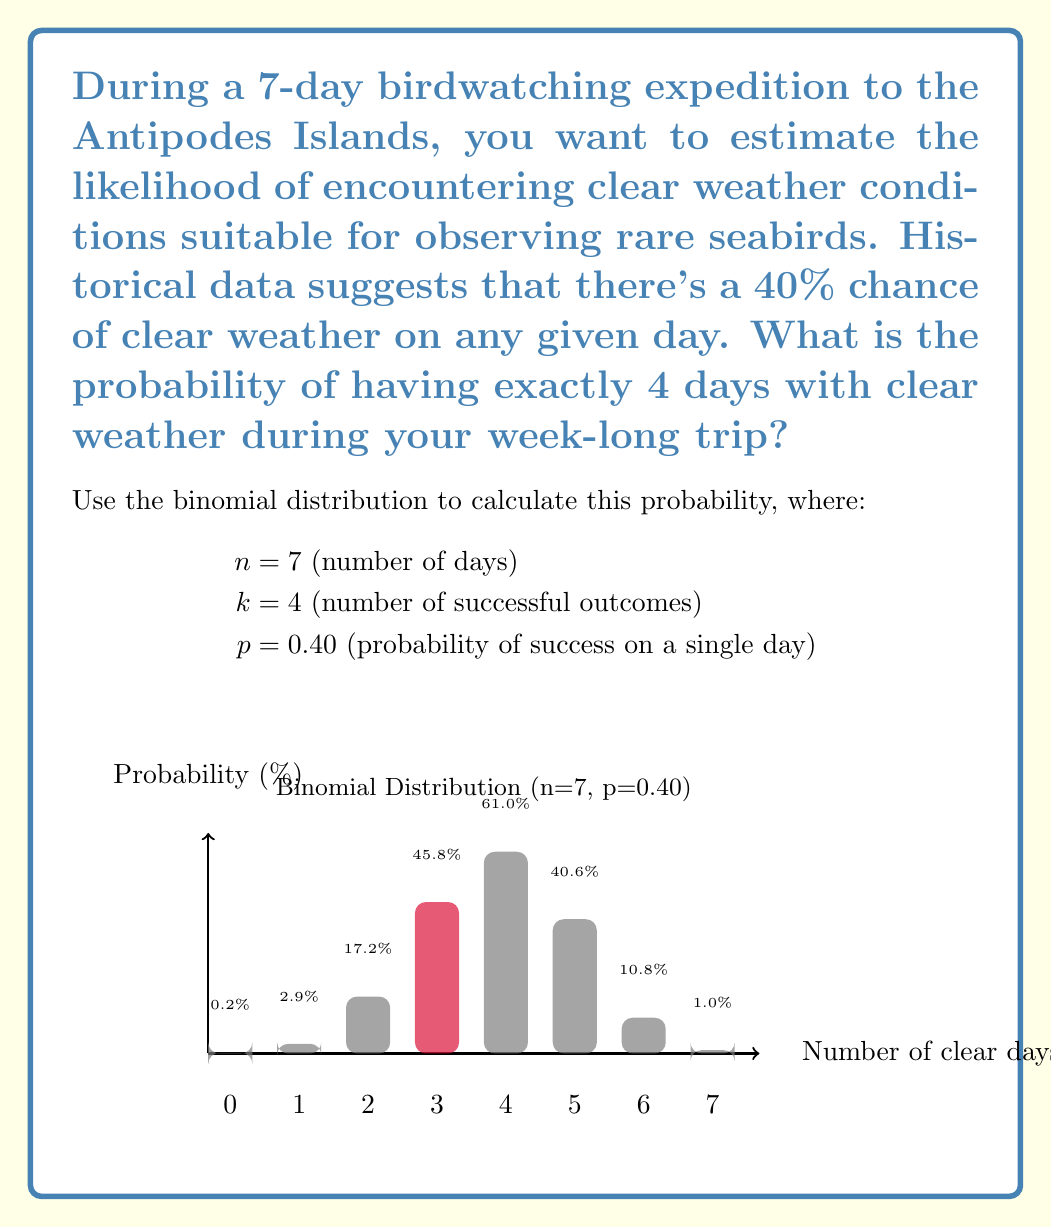Solve this math problem. To solve this problem, we'll use the binomial probability mass function:

$$P(X = k) = \binom{n}{k} p^k (1-p)^{n-k}$$

Where:
$n = 7$ (number of trials)
$k = 4$ (number of successes)
$p = 0.40$ (probability of success on a single trial)

Step 1: Calculate the binomial coefficient $\binom{n}{k}$
$$\binom{7}{4} = \frac{7!}{4!(7-4)!} = \frac{7!}{4!3!} = 35$$

Step 2: Calculate $p^k$
$$0.40^4 = 0.0256$$

Step 3: Calculate $(1-p)^{n-k}$
$$(1-0.40)^{7-4} = 0.60^3 = 0.216$$

Step 4: Multiply the results from steps 1, 2, and 3
$$35 \times 0.0256 \times 0.216 = 0.19353600$$

Step 5: Convert to a percentage
$$0.19353600 \times 100\% = 19.3536\%$$

Therefore, the probability of having exactly 4 clear days during the 7-day birdwatching expedition is approximately 19.35%.
Answer: 19.35% 